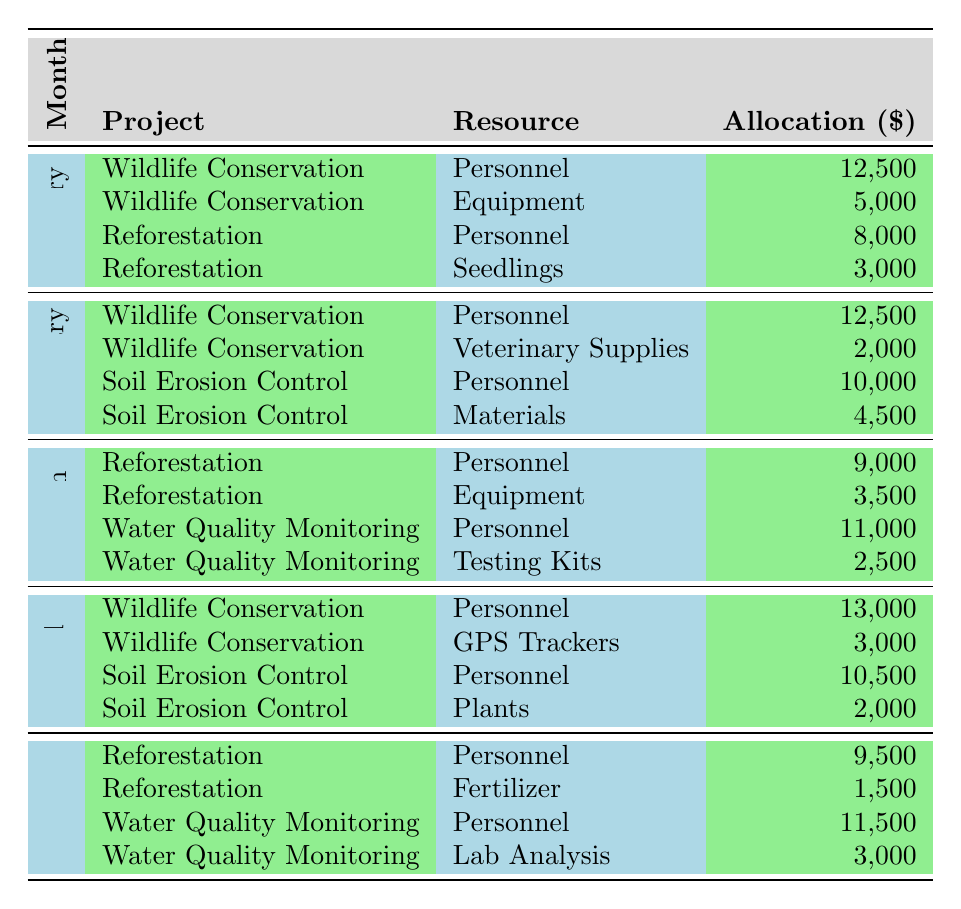What is the total allocation for Wildlife Conservation in February? In February, the allocations for Wildlife Conservation are $12,500 for Personnel and $2,000 for Veterinary Supplies. The total is $12,500 + $2,000 = $14,500.
Answer: $14,500 What resource had the highest allocation in March? In March, the highest allocation is for Water Quality Monitoring Personnel at $11,000. This is higher than any other allocation listed for that month.
Answer: $11,000 How much was allocated to Reforestation in January? In January, the allocations for Reforestation are $8,000 for Personnel and $3,000 for Seedlings. Therefore, the total allocation is $8,000 + $3,000 = $11,000.
Answer: $11,000 Did Soil Erosion Control receive a larger allocation in April than in February? In April, Soil Erosion Control had allocations of $10,500 for Personnel and $2,000 for Plants, totaling $12,500. In February, it received $10,000 for Personnel and $4,500 for Materials, totaling $14,500. Since $12,500 is less than $14,500, the answer is no.
Answer: No What is the average allocation for Personnel across all projects in May? In May, the Personnel allocations are $9,500 for Reforestation and $11,500 for Water Quality Monitoring. The total for Personnel is $9,500 + $11,500 = $21,000. Since there are 2 allocations, the average is $21,000 / 2 = $10,500.
Answer: $10,500 Which project had the lowest total resource allocation in January? In January, the total allocations for Wildlife Conservation are $12,500 + $5,000 = $17,500, and for Reforestation are $8,000 + $3,000 = $11,000. Since $11,000 is less than $17,500, Reforestation had the lowest total allocation in January.
Answer: Reforestation How much more was allocated to Wildlife Conservation in April compared to January? In April, Wildlife Conservation had allocations of $13,000 for Personnel and $3,000 for GPS Trackers, totaling $16,000. In January, the total for Wildlife Conservation was $17,500. The difference is $17,500 - $16,000 = $1,500.
Answer: $1,500 What percentage of the total allocation in March was for Personnel? The total allocation in March is $9,000 (Reforestation Personnel) + $3,500 (Reforestation Equipment) + $11,000 (Water Quality Monitoring Personnel) + $2,500 (Testing Kits) = $26,000. The total allocation for Personnel is $9,000 + $11,000 = $20,000. The percentage is ($20,000 / $26,000) * 100 = 76.92%.
Answer: 76.92% Was the total allocation for Reforestation in February greater than in March? In February, total allocation for Reforestation is not listed; hence it's $0. In March, the total allocation for Reforestation is $9,000 + $3,500 = $12,500. Since $0 is less than $12,500, the answer is no.
Answer: No What is the sum of all allocations for Water Quality Monitoring across the months shown? In the table, Water Quality Monitoring allocations are $11,000 + $2,500 in March and $11,500 + $3,000 in May. The total sum is $11,000 + $2,500 + $11,500 + $3,000 = $28,000.
Answer: $28,000 